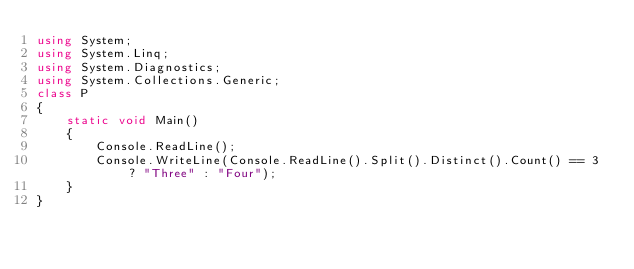Convert code to text. <code><loc_0><loc_0><loc_500><loc_500><_C#_>using System;
using System.Linq;
using System.Diagnostics;
using System.Collections.Generic;
class P
{
    static void Main()
    {
        Console.ReadLine();
        Console.WriteLine(Console.ReadLine().Split().Distinct().Count() == 3 ? "Three" : "Four");
    }
}</code> 